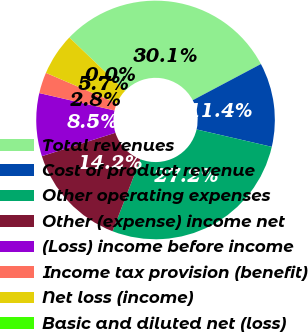Convert chart. <chart><loc_0><loc_0><loc_500><loc_500><pie_chart><fcel>Total revenues<fcel>Cost of product revenue<fcel>Other operating expenses<fcel>Other (expense) income net<fcel>(Loss) income before income<fcel>Income tax provision (benefit)<fcel>Net loss (income)<fcel>Basic and diluted net (loss)<nl><fcel>30.09%<fcel>11.38%<fcel>27.25%<fcel>14.22%<fcel>8.53%<fcel>2.84%<fcel>5.69%<fcel>0.0%<nl></chart> 